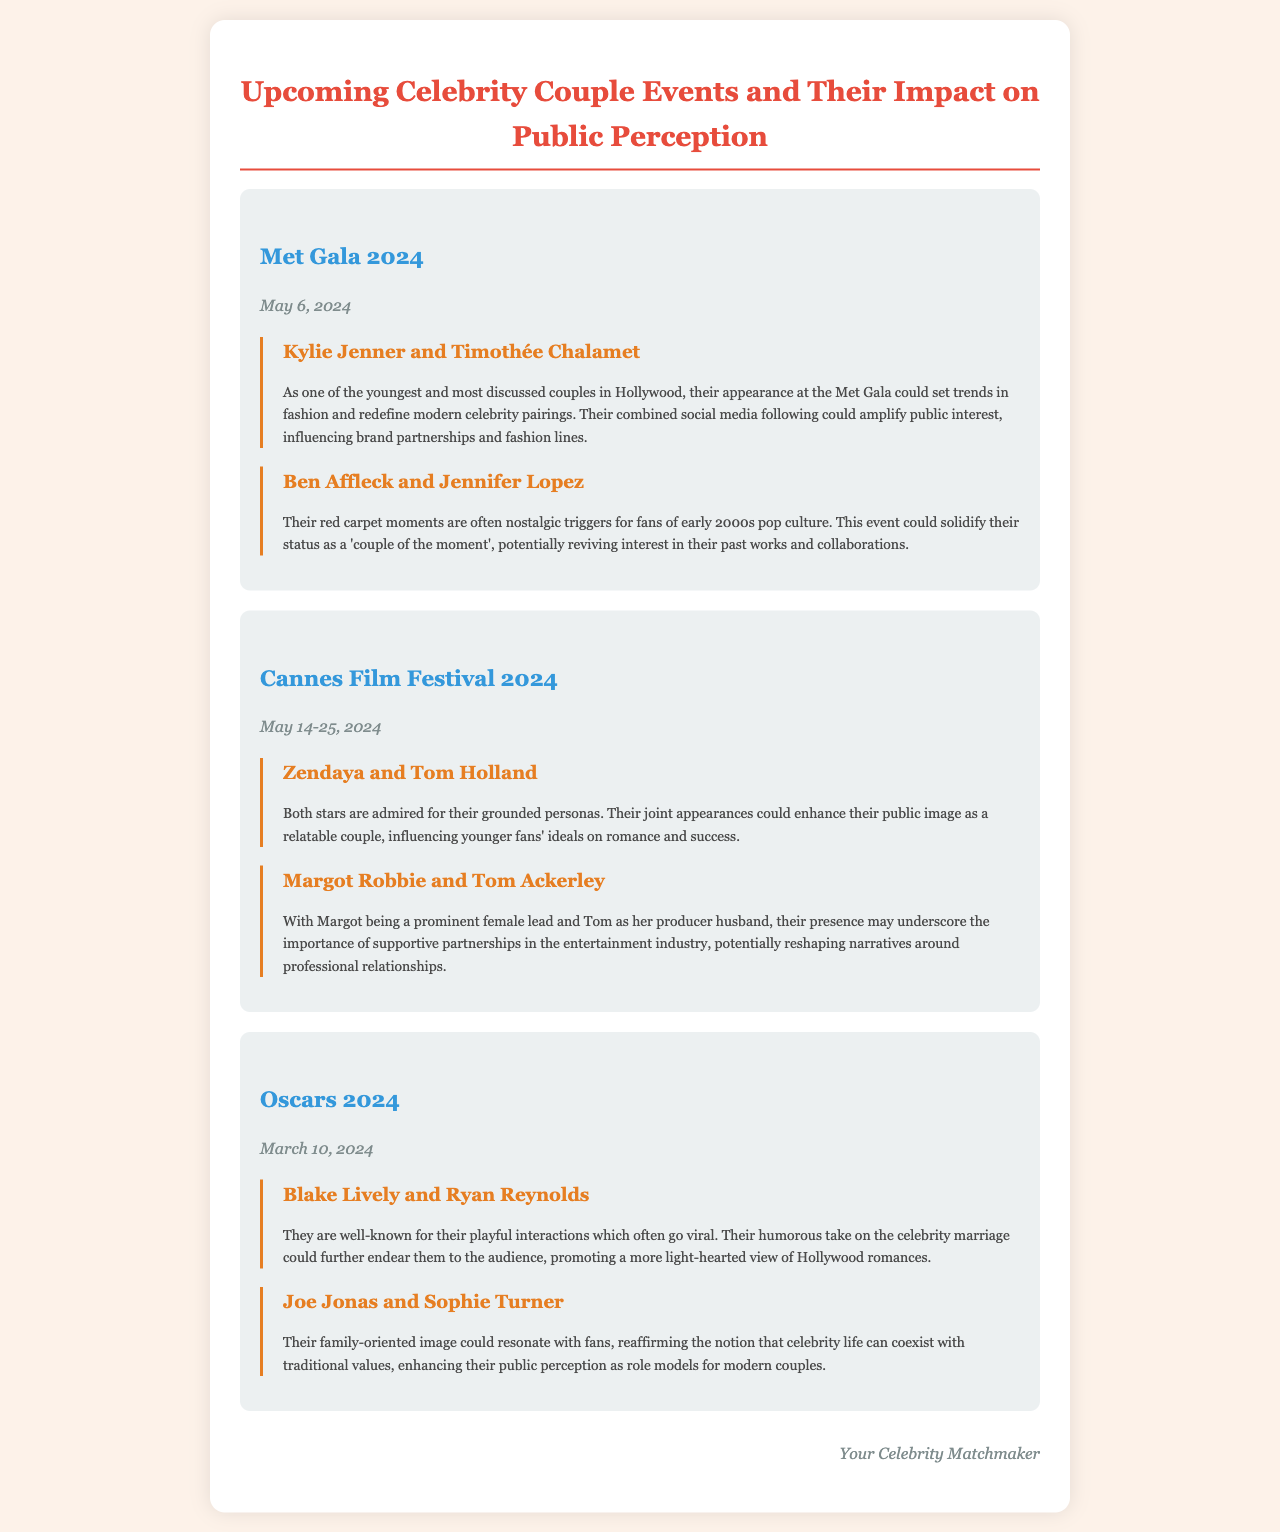What is the date of the Met Gala 2024? The date of the Met Gala is explicitly stated in the document as May 6, 2024.
Answer: May 6, 2024 Who are the couple featured at the Oscars 2024? The document lists Blake Lively and Ryan Reynolds, as well as Joe Jonas and Sophie Turner, as couples featured at the Oscars.
Answer: Blake Lively and Ryan Reynolds; Joe Jonas and Sophie Turner What is the main impact of Kylie Jenner and Timothée Chalamet's appearance? The document mentions that their appearance could set trends in fashion and redefine modern celebrity pairings.
Answer: Set trends in fashion and redefine modern celebrity pairings When does the Cannes Film Festival 2024 take place? The document provides the dates for the Cannes Film Festival as May 14-25, 2024.
Answer: May 14-25, 2024 What sentiment could Blake Lively and Ryan Reynolds promote? It is suggested in the document that their playful interactions could promote a more light-hearted view of Hollywood romances.
Answer: A more light-hearted view of Hollywood romances 